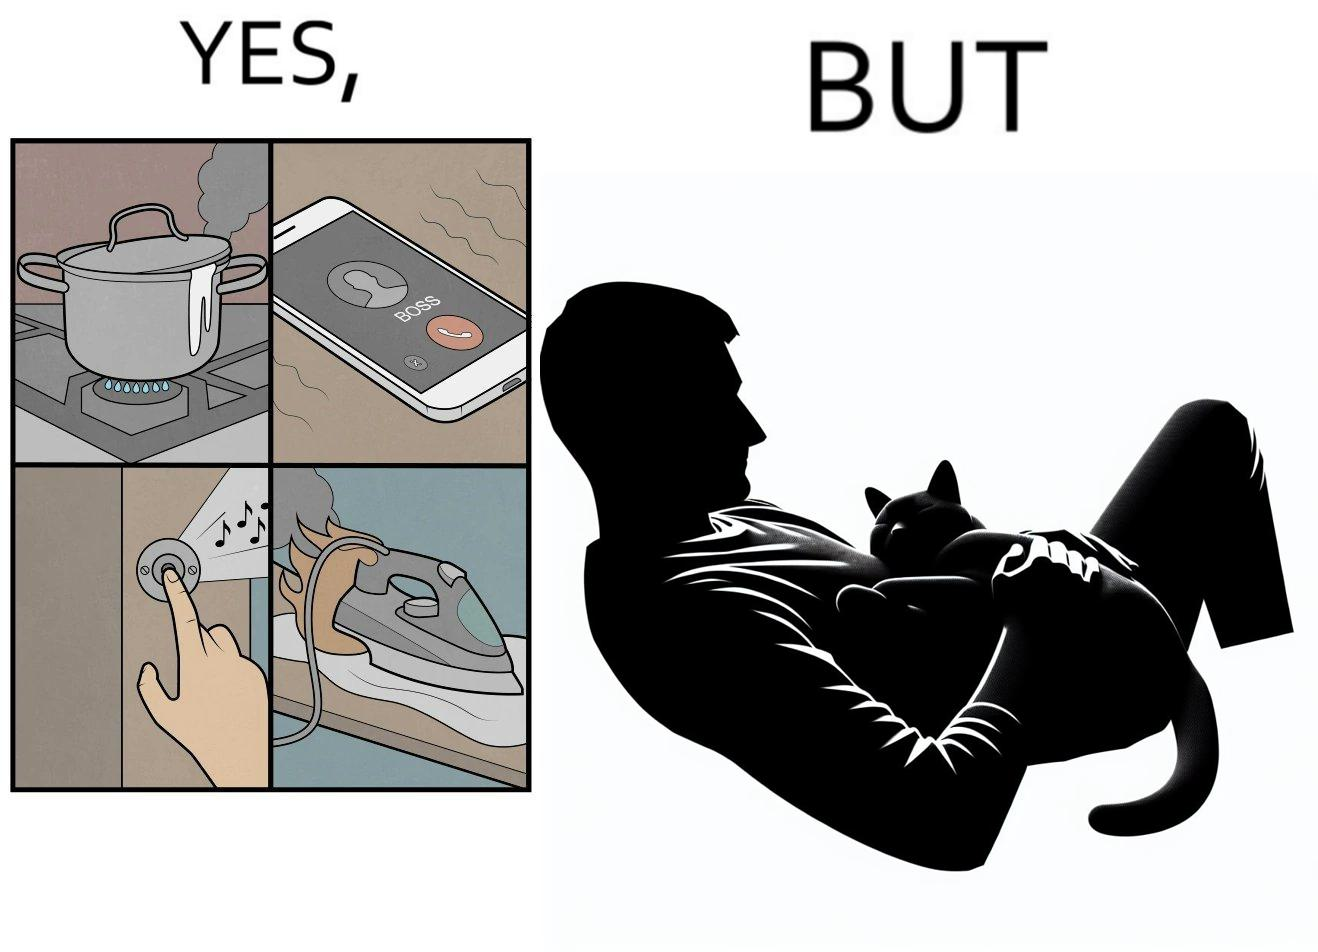Explain why this image is satirical. the irony in this image is that people ignore all the chaos around them and get distracted by a cat. 